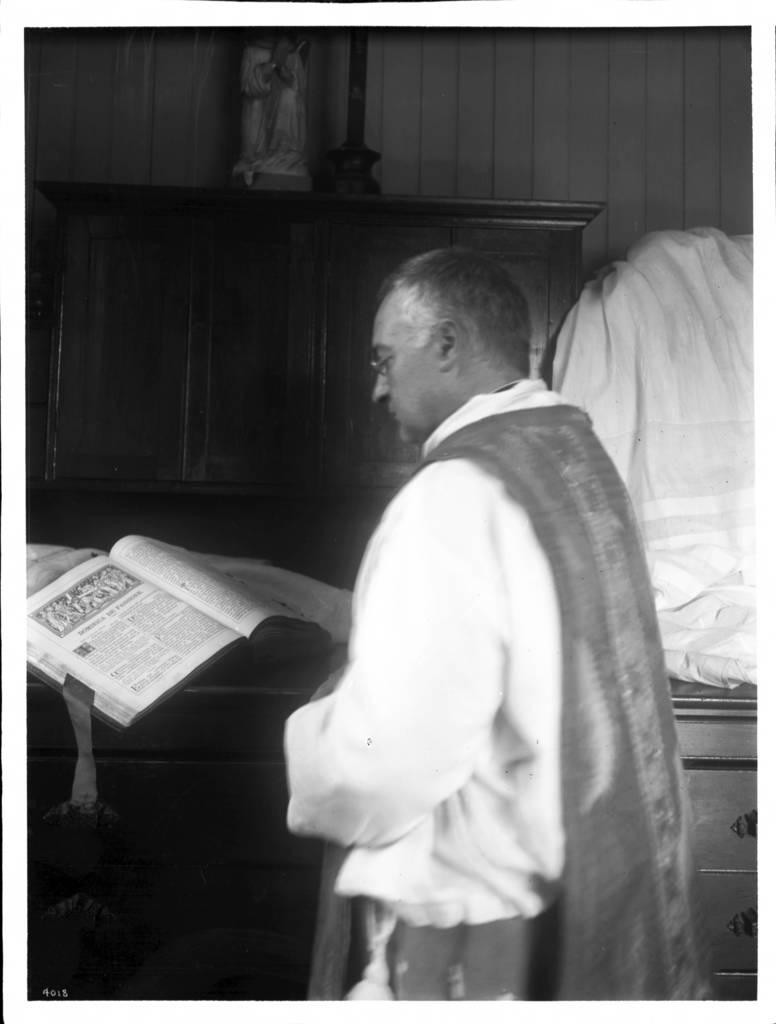What is the color scheme of the image? The image is black and white. What can be seen in the image besides the color scheme? There is a person standing in the image, along with a book, a cloth, and a sculpture on a wooden object in front of the person. How many cats are visible in the image? There are no cats present in the image. What type of bell can be heard ringing in the image? There is no bell present in the image, and therefore no sound can be heard. 